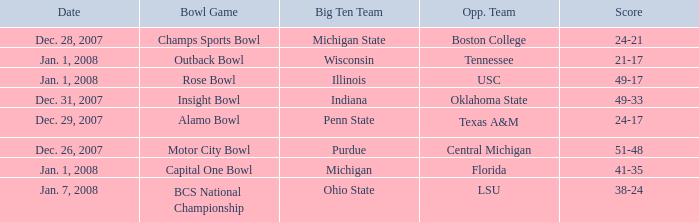What bowl game was played on Dec. 26, 2007? Motor City Bowl. 